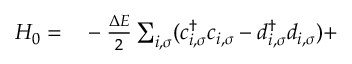<formula> <loc_0><loc_0><loc_500><loc_500>\begin{array} { r l } { H _ { 0 } = } & - \frac { \Delta E } { 2 } \sum _ { i , \sigma } ( c _ { i , \sigma } ^ { \dag } c _ { i , \sigma } - d _ { i , \sigma } ^ { \dag } d _ { i , \sigma } ) + } \end{array}</formula> 